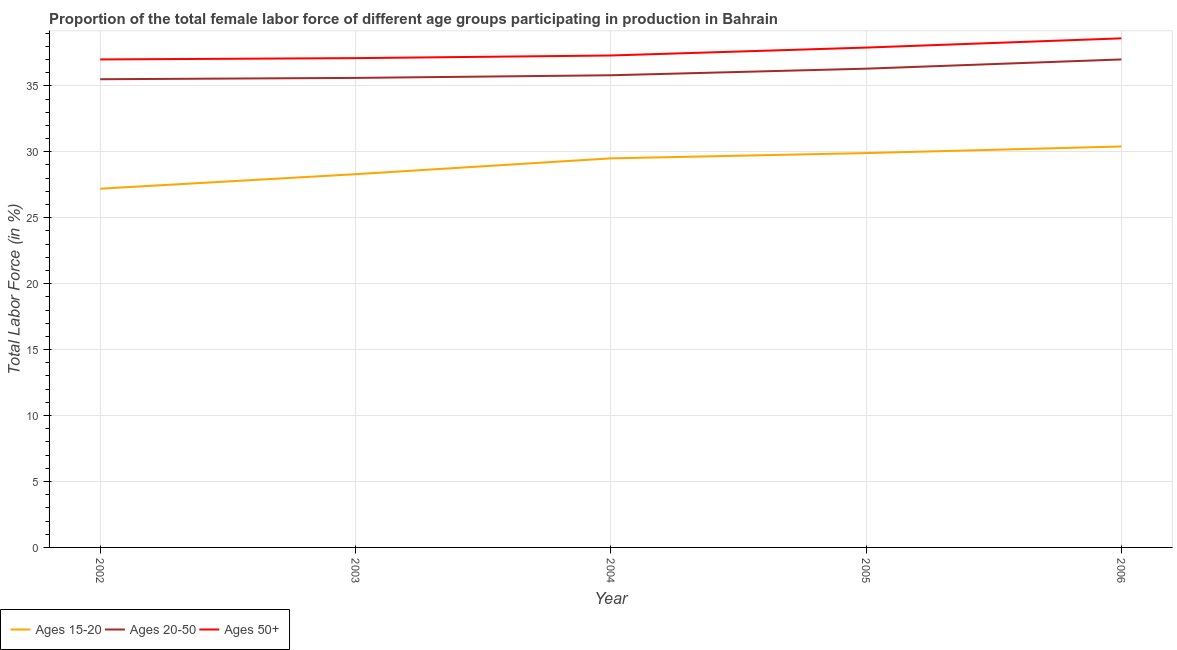How many different coloured lines are there?
Ensure brevity in your answer.  3. Is the number of lines equal to the number of legend labels?
Ensure brevity in your answer.  Yes. What is the percentage of female labor force within the age group 15-20 in 2003?
Your response must be concise. 28.3. Across all years, what is the maximum percentage of female labor force above age 50?
Offer a terse response. 38.6. Across all years, what is the minimum percentage of female labor force within the age group 15-20?
Ensure brevity in your answer.  27.2. In which year was the percentage of female labor force above age 50 maximum?
Ensure brevity in your answer.  2006. What is the total percentage of female labor force within the age group 15-20 in the graph?
Keep it short and to the point. 145.3. What is the difference between the percentage of female labor force within the age group 15-20 in 2003 and that in 2005?
Offer a terse response. -1.6. What is the difference between the percentage of female labor force within the age group 20-50 in 2006 and the percentage of female labor force within the age group 15-20 in 2003?
Make the answer very short. 8.7. What is the average percentage of female labor force within the age group 20-50 per year?
Keep it short and to the point. 36.04. In the year 2006, what is the difference between the percentage of female labor force within the age group 20-50 and percentage of female labor force within the age group 15-20?
Offer a very short reply. 6.6. In how many years, is the percentage of female labor force within the age group 15-20 greater than 4 %?
Ensure brevity in your answer.  5. What is the ratio of the percentage of female labor force within the age group 20-50 in 2003 to that in 2004?
Ensure brevity in your answer.  0.99. Is the percentage of female labor force above age 50 in 2003 less than that in 2006?
Give a very brief answer. Yes. What is the difference between the highest and the second highest percentage of female labor force within the age group 20-50?
Your answer should be very brief. 0.7. What is the difference between the highest and the lowest percentage of female labor force within the age group 15-20?
Make the answer very short. 3.2. Does the percentage of female labor force within the age group 20-50 monotonically increase over the years?
Keep it short and to the point. Yes. Is the percentage of female labor force within the age group 15-20 strictly greater than the percentage of female labor force within the age group 20-50 over the years?
Provide a succinct answer. No. Is the percentage of female labor force within the age group 15-20 strictly less than the percentage of female labor force above age 50 over the years?
Your answer should be very brief. Yes. Does the graph contain any zero values?
Provide a succinct answer. No. Does the graph contain grids?
Provide a succinct answer. Yes. Where does the legend appear in the graph?
Provide a short and direct response. Bottom left. How many legend labels are there?
Keep it short and to the point. 3. What is the title of the graph?
Offer a very short reply. Proportion of the total female labor force of different age groups participating in production in Bahrain. Does "Taxes on international trade" appear as one of the legend labels in the graph?
Provide a succinct answer. No. What is the label or title of the X-axis?
Give a very brief answer. Year. What is the label or title of the Y-axis?
Provide a short and direct response. Total Labor Force (in %). What is the Total Labor Force (in %) of Ages 15-20 in 2002?
Your response must be concise. 27.2. What is the Total Labor Force (in %) of Ages 20-50 in 2002?
Your answer should be very brief. 35.5. What is the Total Labor Force (in %) in Ages 50+ in 2002?
Offer a very short reply. 37. What is the Total Labor Force (in %) of Ages 15-20 in 2003?
Keep it short and to the point. 28.3. What is the Total Labor Force (in %) of Ages 20-50 in 2003?
Offer a terse response. 35.6. What is the Total Labor Force (in %) of Ages 50+ in 2003?
Make the answer very short. 37.1. What is the Total Labor Force (in %) in Ages 15-20 in 2004?
Keep it short and to the point. 29.5. What is the Total Labor Force (in %) of Ages 20-50 in 2004?
Your answer should be very brief. 35.8. What is the Total Labor Force (in %) in Ages 50+ in 2004?
Ensure brevity in your answer.  37.3. What is the Total Labor Force (in %) of Ages 15-20 in 2005?
Your answer should be very brief. 29.9. What is the Total Labor Force (in %) of Ages 20-50 in 2005?
Your response must be concise. 36.3. What is the Total Labor Force (in %) in Ages 50+ in 2005?
Provide a short and direct response. 37.9. What is the Total Labor Force (in %) of Ages 15-20 in 2006?
Keep it short and to the point. 30.4. What is the Total Labor Force (in %) in Ages 20-50 in 2006?
Offer a terse response. 37. What is the Total Labor Force (in %) in Ages 50+ in 2006?
Keep it short and to the point. 38.6. Across all years, what is the maximum Total Labor Force (in %) of Ages 15-20?
Ensure brevity in your answer.  30.4. Across all years, what is the maximum Total Labor Force (in %) in Ages 50+?
Provide a succinct answer. 38.6. Across all years, what is the minimum Total Labor Force (in %) in Ages 15-20?
Your answer should be very brief. 27.2. Across all years, what is the minimum Total Labor Force (in %) in Ages 20-50?
Offer a terse response. 35.5. Across all years, what is the minimum Total Labor Force (in %) in Ages 50+?
Provide a succinct answer. 37. What is the total Total Labor Force (in %) of Ages 15-20 in the graph?
Make the answer very short. 145.3. What is the total Total Labor Force (in %) in Ages 20-50 in the graph?
Keep it short and to the point. 180.2. What is the total Total Labor Force (in %) in Ages 50+ in the graph?
Make the answer very short. 187.9. What is the difference between the Total Labor Force (in %) in Ages 20-50 in 2002 and that in 2003?
Ensure brevity in your answer.  -0.1. What is the difference between the Total Labor Force (in %) in Ages 15-20 in 2002 and that in 2004?
Provide a succinct answer. -2.3. What is the difference between the Total Labor Force (in %) of Ages 20-50 in 2002 and that in 2004?
Your response must be concise. -0.3. What is the difference between the Total Labor Force (in %) of Ages 50+ in 2002 and that in 2004?
Keep it short and to the point. -0.3. What is the difference between the Total Labor Force (in %) in Ages 15-20 in 2002 and that in 2005?
Your answer should be very brief. -2.7. What is the difference between the Total Labor Force (in %) of Ages 20-50 in 2002 and that in 2005?
Offer a terse response. -0.8. What is the difference between the Total Labor Force (in %) in Ages 20-50 in 2002 and that in 2006?
Offer a very short reply. -1.5. What is the difference between the Total Labor Force (in %) in Ages 20-50 in 2003 and that in 2004?
Provide a short and direct response. -0.2. What is the difference between the Total Labor Force (in %) of Ages 50+ in 2003 and that in 2004?
Provide a short and direct response. -0.2. What is the difference between the Total Labor Force (in %) in Ages 20-50 in 2003 and that in 2005?
Make the answer very short. -0.7. What is the difference between the Total Labor Force (in %) in Ages 50+ in 2003 and that in 2005?
Make the answer very short. -0.8. What is the difference between the Total Labor Force (in %) of Ages 50+ in 2003 and that in 2006?
Give a very brief answer. -1.5. What is the difference between the Total Labor Force (in %) in Ages 20-50 in 2004 and that in 2005?
Provide a short and direct response. -0.5. What is the difference between the Total Labor Force (in %) of Ages 15-20 in 2004 and that in 2006?
Give a very brief answer. -0.9. What is the difference between the Total Labor Force (in %) in Ages 20-50 in 2004 and that in 2006?
Keep it short and to the point. -1.2. What is the difference between the Total Labor Force (in %) of Ages 50+ in 2004 and that in 2006?
Make the answer very short. -1.3. What is the difference between the Total Labor Force (in %) of Ages 15-20 in 2005 and that in 2006?
Your answer should be compact. -0.5. What is the difference between the Total Labor Force (in %) of Ages 20-50 in 2005 and that in 2006?
Give a very brief answer. -0.7. What is the difference between the Total Labor Force (in %) in Ages 15-20 in 2002 and the Total Labor Force (in %) in Ages 20-50 in 2004?
Provide a short and direct response. -8.6. What is the difference between the Total Labor Force (in %) in Ages 20-50 in 2002 and the Total Labor Force (in %) in Ages 50+ in 2004?
Your answer should be compact. -1.8. What is the difference between the Total Labor Force (in %) of Ages 15-20 in 2002 and the Total Labor Force (in %) of Ages 50+ in 2006?
Offer a very short reply. -11.4. What is the difference between the Total Labor Force (in %) in Ages 20-50 in 2002 and the Total Labor Force (in %) in Ages 50+ in 2006?
Give a very brief answer. -3.1. What is the difference between the Total Labor Force (in %) of Ages 15-20 in 2003 and the Total Labor Force (in %) of Ages 50+ in 2004?
Provide a short and direct response. -9. What is the difference between the Total Labor Force (in %) of Ages 20-50 in 2003 and the Total Labor Force (in %) of Ages 50+ in 2004?
Give a very brief answer. -1.7. What is the difference between the Total Labor Force (in %) of Ages 15-20 in 2004 and the Total Labor Force (in %) of Ages 50+ in 2005?
Your answer should be very brief. -8.4. What is the difference between the Total Labor Force (in %) of Ages 20-50 in 2004 and the Total Labor Force (in %) of Ages 50+ in 2005?
Provide a short and direct response. -2.1. What is the difference between the Total Labor Force (in %) in Ages 15-20 in 2004 and the Total Labor Force (in %) in Ages 50+ in 2006?
Offer a very short reply. -9.1. What is the difference between the Total Labor Force (in %) in Ages 20-50 in 2004 and the Total Labor Force (in %) in Ages 50+ in 2006?
Your answer should be compact. -2.8. What is the difference between the Total Labor Force (in %) of Ages 15-20 in 2005 and the Total Labor Force (in %) of Ages 50+ in 2006?
Provide a short and direct response. -8.7. What is the average Total Labor Force (in %) in Ages 15-20 per year?
Keep it short and to the point. 29.06. What is the average Total Labor Force (in %) of Ages 20-50 per year?
Provide a short and direct response. 36.04. What is the average Total Labor Force (in %) in Ages 50+ per year?
Your answer should be very brief. 37.58. In the year 2002, what is the difference between the Total Labor Force (in %) of Ages 15-20 and Total Labor Force (in %) of Ages 20-50?
Provide a succinct answer. -8.3. In the year 2002, what is the difference between the Total Labor Force (in %) in Ages 20-50 and Total Labor Force (in %) in Ages 50+?
Provide a short and direct response. -1.5. In the year 2005, what is the difference between the Total Labor Force (in %) in Ages 15-20 and Total Labor Force (in %) in Ages 20-50?
Provide a short and direct response. -6.4. In the year 2005, what is the difference between the Total Labor Force (in %) of Ages 15-20 and Total Labor Force (in %) of Ages 50+?
Offer a very short reply. -8. In the year 2006, what is the difference between the Total Labor Force (in %) in Ages 15-20 and Total Labor Force (in %) in Ages 20-50?
Your answer should be very brief. -6.6. In the year 2006, what is the difference between the Total Labor Force (in %) in Ages 15-20 and Total Labor Force (in %) in Ages 50+?
Provide a succinct answer. -8.2. In the year 2006, what is the difference between the Total Labor Force (in %) of Ages 20-50 and Total Labor Force (in %) of Ages 50+?
Keep it short and to the point. -1.6. What is the ratio of the Total Labor Force (in %) of Ages 15-20 in 2002 to that in 2003?
Keep it short and to the point. 0.96. What is the ratio of the Total Labor Force (in %) in Ages 20-50 in 2002 to that in 2003?
Offer a very short reply. 1. What is the ratio of the Total Labor Force (in %) of Ages 50+ in 2002 to that in 2003?
Offer a terse response. 1. What is the ratio of the Total Labor Force (in %) of Ages 15-20 in 2002 to that in 2004?
Provide a succinct answer. 0.92. What is the ratio of the Total Labor Force (in %) in Ages 20-50 in 2002 to that in 2004?
Your answer should be compact. 0.99. What is the ratio of the Total Labor Force (in %) in Ages 50+ in 2002 to that in 2004?
Your response must be concise. 0.99. What is the ratio of the Total Labor Force (in %) of Ages 15-20 in 2002 to that in 2005?
Your answer should be very brief. 0.91. What is the ratio of the Total Labor Force (in %) in Ages 50+ in 2002 to that in 2005?
Your answer should be very brief. 0.98. What is the ratio of the Total Labor Force (in %) in Ages 15-20 in 2002 to that in 2006?
Give a very brief answer. 0.89. What is the ratio of the Total Labor Force (in %) in Ages 20-50 in 2002 to that in 2006?
Your response must be concise. 0.96. What is the ratio of the Total Labor Force (in %) of Ages 50+ in 2002 to that in 2006?
Your answer should be very brief. 0.96. What is the ratio of the Total Labor Force (in %) in Ages 15-20 in 2003 to that in 2004?
Provide a short and direct response. 0.96. What is the ratio of the Total Labor Force (in %) in Ages 20-50 in 2003 to that in 2004?
Provide a short and direct response. 0.99. What is the ratio of the Total Labor Force (in %) in Ages 15-20 in 2003 to that in 2005?
Provide a succinct answer. 0.95. What is the ratio of the Total Labor Force (in %) in Ages 20-50 in 2003 to that in 2005?
Provide a short and direct response. 0.98. What is the ratio of the Total Labor Force (in %) in Ages 50+ in 2003 to that in 2005?
Offer a very short reply. 0.98. What is the ratio of the Total Labor Force (in %) in Ages 15-20 in 2003 to that in 2006?
Provide a succinct answer. 0.93. What is the ratio of the Total Labor Force (in %) in Ages 20-50 in 2003 to that in 2006?
Provide a succinct answer. 0.96. What is the ratio of the Total Labor Force (in %) of Ages 50+ in 2003 to that in 2006?
Keep it short and to the point. 0.96. What is the ratio of the Total Labor Force (in %) in Ages 15-20 in 2004 to that in 2005?
Give a very brief answer. 0.99. What is the ratio of the Total Labor Force (in %) in Ages 20-50 in 2004 to that in 2005?
Give a very brief answer. 0.99. What is the ratio of the Total Labor Force (in %) of Ages 50+ in 2004 to that in 2005?
Keep it short and to the point. 0.98. What is the ratio of the Total Labor Force (in %) of Ages 15-20 in 2004 to that in 2006?
Ensure brevity in your answer.  0.97. What is the ratio of the Total Labor Force (in %) of Ages 20-50 in 2004 to that in 2006?
Provide a short and direct response. 0.97. What is the ratio of the Total Labor Force (in %) in Ages 50+ in 2004 to that in 2006?
Make the answer very short. 0.97. What is the ratio of the Total Labor Force (in %) of Ages 15-20 in 2005 to that in 2006?
Your answer should be compact. 0.98. What is the ratio of the Total Labor Force (in %) of Ages 20-50 in 2005 to that in 2006?
Make the answer very short. 0.98. What is the ratio of the Total Labor Force (in %) of Ages 50+ in 2005 to that in 2006?
Your answer should be compact. 0.98. What is the difference between the highest and the second highest Total Labor Force (in %) of Ages 15-20?
Ensure brevity in your answer.  0.5. What is the difference between the highest and the second highest Total Labor Force (in %) of Ages 50+?
Your answer should be very brief. 0.7. What is the difference between the highest and the lowest Total Labor Force (in %) of Ages 15-20?
Your answer should be very brief. 3.2. 